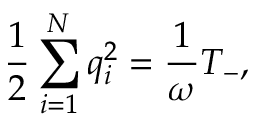Convert formula to latex. <formula><loc_0><loc_0><loc_500><loc_500>\frac { 1 } { 2 } \sum _ { i = 1 } ^ { N } q _ { i } ^ { 2 } = \frac { 1 } { \omega } T _ { - } ,</formula> 